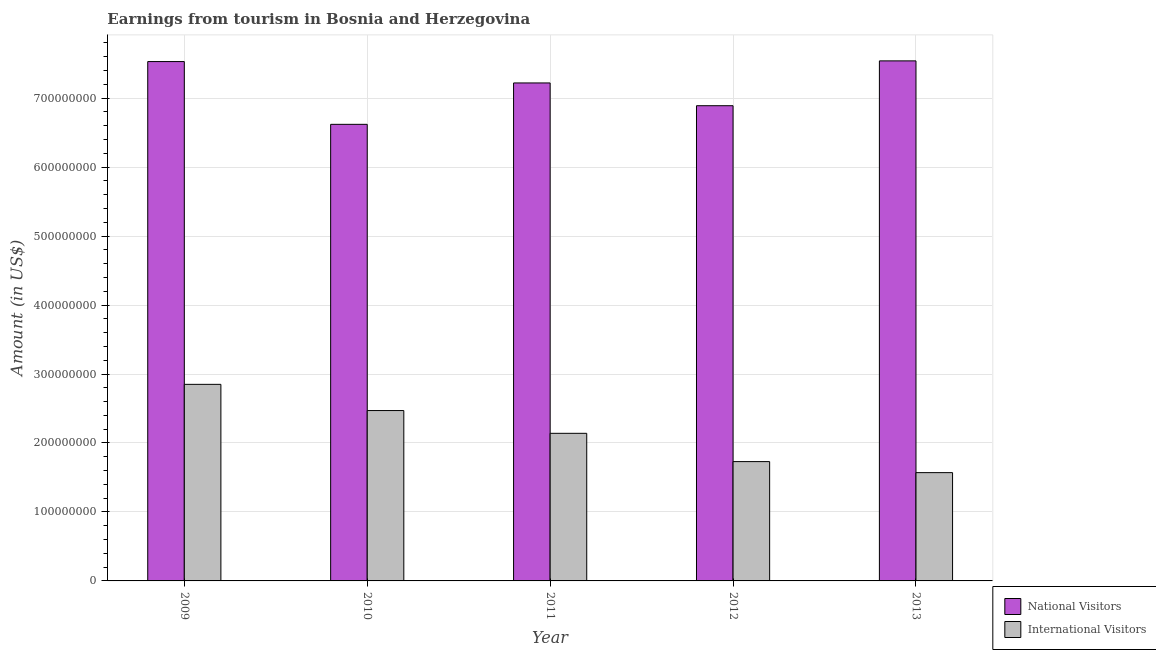Are the number of bars per tick equal to the number of legend labels?
Offer a terse response. Yes. How many bars are there on the 5th tick from the right?
Your response must be concise. 2. What is the label of the 4th group of bars from the left?
Give a very brief answer. 2012. In how many cases, is the number of bars for a given year not equal to the number of legend labels?
Offer a terse response. 0. What is the amount earned from national visitors in 2012?
Provide a short and direct response. 6.89e+08. Across all years, what is the maximum amount earned from national visitors?
Offer a very short reply. 7.54e+08. Across all years, what is the minimum amount earned from national visitors?
Ensure brevity in your answer.  6.62e+08. In which year was the amount earned from international visitors minimum?
Your answer should be compact. 2013. What is the total amount earned from national visitors in the graph?
Offer a very short reply. 3.58e+09. What is the difference between the amount earned from national visitors in 2010 and that in 2012?
Offer a very short reply. -2.70e+07. What is the difference between the amount earned from international visitors in 2013 and the amount earned from national visitors in 2010?
Offer a terse response. -9.00e+07. What is the average amount earned from national visitors per year?
Make the answer very short. 7.16e+08. In the year 2010, what is the difference between the amount earned from international visitors and amount earned from national visitors?
Offer a terse response. 0. In how many years, is the amount earned from international visitors greater than 480000000 US$?
Provide a short and direct response. 0. What is the ratio of the amount earned from international visitors in 2009 to that in 2010?
Provide a short and direct response. 1.15. Is the amount earned from international visitors in 2010 less than that in 2012?
Your response must be concise. No. What is the difference between the highest and the second highest amount earned from international visitors?
Ensure brevity in your answer.  3.80e+07. What is the difference between the highest and the lowest amount earned from national visitors?
Make the answer very short. 9.20e+07. In how many years, is the amount earned from international visitors greater than the average amount earned from international visitors taken over all years?
Offer a terse response. 2. Is the sum of the amount earned from national visitors in 2012 and 2013 greater than the maximum amount earned from international visitors across all years?
Keep it short and to the point. Yes. What does the 1st bar from the left in 2012 represents?
Provide a succinct answer. National Visitors. What does the 2nd bar from the right in 2009 represents?
Offer a terse response. National Visitors. What is the difference between two consecutive major ticks on the Y-axis?
Make the answer very short. 1.00e+08. Are the values on the major ticks of Y-axis written in scientific E-notation?
Your answer should be compact. No. Where does the legend appear in the graph?
Give a very brief answer. Bottom right. How are the legend labels stacked?
Offer a very short reply. Vertical. What is the title of the graph?
Keep it short and to the point. Earnings from tourism in Bosnia and Herzegovina. Does "Passenger Transport Items" appear as one of the legend labels in the graph?
Your response must be concise. No. What is the label or title of the X-axis?
Keep it short and to the point. Year. What is the Amount (in US$) of National Visitors in 2009?
Keep it short and to the point. 7.53e+08. What is the Amount (in US$) in International Visitors in 2009?
Your answer should be compact. 2.85e+08. What is the Amount (in US$) in National Visitors in 2010?
Give a very brief answer. 6.62e+08. What is the Amount (in US$) of International Visitors in 2010?
Offer a terse response. 2.47e+08. What is the Amount (in US$) in National Visitors in 2011?
Keep it short and to the point. 7.22e+08. What is the Amount (in US$) in International Visitors in 2011?
Your answer should be very brief. 2.14e+08. What is the Amount (in US$) of National Visitors in 2012?
Give a very brief answer. 6.89e+08. What is the Amount (in US$) in International Visitors in 2012?
Your answer should be very brief. 1.73e+08. What is the Amount (in US$) in National Visitors in 2013?
Keep it short and to the point. 7.54e+08. What is the Amount (in US$) in International Visitors in 2013?
Ensure brevity in your answer.  1.57e+08. Across all years, what is the maximum Amount (in US$) of National Visitors?
Your answer should be compact. 7.54e+08. Across all years, what is the maximum Amount (in US$) of International Visitors?
Ensure brevity in your answer.  2.85e+08. Across all years, what is the minimum Amount (in US$) in National Visitors?
Make the answer very short. 6.62e+08. Across all years, what is the minimum Amount (in US$) of International Visitors?
Provide a succinct answer. 1.57e+08. What is the total Amount (in US$) of National Visitors in the graph?
Ensure brevity in your answer.  3.58e+09. What is the total Amount (in US$) of International Visitors in the graph?
Make the answer very short. 1.08e+09. What is the difference between the Amount (in US$) of National Visitors in 2009 and that in 2010?
Ensure brevity in your answer.  9.10e+07. What is the difference between the Amount (in US$) in International Visitors in 2009 and that in 2010?
Your answer should be very brief. 3.80e+07. What is the difference between the Amount (in US$) in National Visitors in 2009 and that in 2011?
Provide a succinct answer. 3.10e+07. What is the difference between the Amount (in US$) of International Visitors in 2009 and that in 2011?
Offer a terse response. 7.10e+07. What is the difference between the Amount (in US$) of National Visitors in 2009 and that in 2012?
Give a very brief answer. 6.40e+07. What is the difference between the Amount (in US$) of International Visitors in 2009 and that in 2012?
Give a very brief answer. 1.12e+08. What is the difference between the Amount (in US$) of National Visitors in 2009 and that in 2013?
Your answer should be compact. -1.00e+06. What is the difference between the Amount (in US$) of International Visitors in 2009 and that in 2013?
Keep it short and to the point. 1.28e+08. What is the difference between the Amount (in US$) in National Visitors in 2010 and that in 2011?
Your answer should be very brief. -6.00e+07. What is the difference between the Amount (in US$) of International Visitors in 2010 and that in 2011?
Your response must be concise. 3.30e+07. What is the difference between the Amount (in US$) in National Visitors in 2010 and that in 2012?
Offer a terse response. -2.70e+07. What is the difference between the Amount (in US$) in International Visitors in 2010 and that in 2012?
Your answer should be very brief. 7.40e+07. What is the difference between the Amount (in US$) in National Visitors in 2010 and that in 2013?
Your answer should be very brief. -9.20e+07. What is the difference between the Amount (in US$) in International Visitors in 2010 and that in 2013?
Offer a terse response. 9.00e+07. What is the difference between the Amount (in US$) in National Visitors in 2011 and that in 2012?
Your answer should be very brief. 3.30e+07. What is the difference between the Amount (in US$) in International Visitors in 2011 and that in 2012?
Your answer should be very brief. 4.10e+07. What is the difference between the Amount (in US$) in National Visitors in 2011 and that in 2013?
Your answer should be very brief. -3.20e+07. What is the difference between the Amount (in US$) of International Visitors in 2011 and that in 2013?
Your response must be concise. 5.70e+07. What is the difference between the Amount (in US$) of National Visitors in 2012 and that in 2013?
Offer a terse response. -6.50e+07. What is the difference between the Amount (in US$) of International Visitors in 2012 and that in 2013?
Keep it short and to the point. 1.60e+07. What is the difference between the Amount (in US$) in National Visitors in 2009 and the Amount (in US$) in International Visitors in 2010?
Make the answer very short. 5.06e+08. What is the difference between the Amount (in US$) in National Visitors in 2009 and the Amount (in US$) in International Visitors in 2011?
Ensure brevity in your answer.  5.39e+08. What is the difference between the Amount (in US$) of National Visitors in 2009 and the Amount (in US$) of International Visitors in 2012?
Your answer should be very brief. 5.80e+08. What is the difference between the Amount (in US$) in National Visitors in 2009 and the Amount (in US$) in International Visitors in 2013?
Your response must be concise. 5.96e+08. What is the difference between the Amount (in US$) of National Visitors in 2010 and the Amount (in US$) of International Visitors in 2011?
Provide a short and direct response. 4.48e+08. What is the difference between the Amount (in US$) of National Visitors in 2010 and the Amount (in US$) of International Visitors in 2012?
Your response must be concise. 4.89e+08. What is the difference between the Amount (in US$) in National Visitors in 2010 and the Amount (in US$) in International Visitors in 2013?
Offer a terse response. 5.05e+08. What is the difference between the Amount (in US$) of National Visitors in 2011 and the Amount (in US$) of International Visitors in 2012?
Ensure brevity in your answer.  5.49e+08. What is the difference between the Amount (in US$) in National Visitors in 2011 and the Amount (in US$) in International Visitors in 2013?
Ensure brevity in your answer.  5.65e+08. What is the difference between the Amount (in US$) in National Visitors in 2012 and the Amount (in US$) in International Visitors in 2013?
Your response must be concise. 5.32e+08. What is the average Amount (in US$) of National Visitors per year?
Provide a short and direct response. 7.16e+08. What is the average Amount (in US$) in International Visitors per year?
Provide a short and direct response. 2.15e+08. In the year 2009, what is the difference between the Amount (in US$) in National Visitors and Amount (in US$) in International Visitors?
Your answer should be compact. 4.68e+08. In the year 2010, what is the difference between the Amount (in US$) of National Visitors and Amount (in US$) of International Visitors?
Provide a short and direct response. 4.15e+08. In the year 2011, what is the difference between the Amount (in US$) of National Visitors and Amount (in US$) of International Visitors?
Offer a terse response. 5.08e+08. In the year 2012, what is the difference between the Amount (in US$) of National Visitors and Amount (in US$) of International Visitors?
Ensure brevity in your answer.  5.16e+08. In the year 2013, what is the difference between the Amount (in US$) of National Visitors and Amount (in US$) of International Visitors?
Offer a terse response. 5.97e+08. What is the ratio of the Amount (in US$) of National Visitors in 2009 to that in 2010?
Your response must be concise. 1.14. What is the ratio of the Amount (in US$) of International Visitors in 2009 to that in 2010?
Keep it short and to the point. 1.15. What is the ratio of the Amount (in US$) in National Visitors in 2009 to that in 2011?
Your answer should be compact. 1.04. What is the ratio of the Amount (in US$) in International Visitors in 2009 to that in 2011?
Make the answer very short. 1.33. What is the ratio of the Amount (in US$) of National Visitors in 2009 to that in 2012?
Your answer should be very brief. 1.09. What is the ratio of the Amount (in US$) in International Visitors in 2009 to that in 2012?
Provide a succinct answer. 1.65. What is the ratio of the Amount (in US$) of International Visitors in 2009 to that in 2013?
Your answer should be very brief. 1.82. What is the ratio of the Amount (in US$) in National Visitors in 2010 to that in 2011?
Your answer should be compact. 0.92. What is the ratio of the Amount (in US$) in International Visitors in 2010 to that in 2011?
Provide a succinct answer. 1.15. What is the ratio of the Amount (in US$) in National Visitors in 2010 to that in 2012?
Your answer should be compact. 0.96. What is the ratio of the Amount (in US$) in International Visitors in 2010 to that in 2012?
Offer a terse response. 1.43. What is the ratio of the Amount (in US$) in National Visitors in 2010 to that in 2013?
Give a very brief answer. 0.88. What is the ratio of the Amount (in US$) of International Visitors in 2010 to that in 2013?
Keep it short and to the point. 1.57. What is the ratio of the Amount (in US$) of National Visitors in 2011 to that in 2012?
Your response must be concise. 1.05. What is the ratio of the Amount (in US$) in International Visitors in 2011 to that in 2012?
Make the answer very short. 1.24. What is the ratio of the Amount (in US$) of National Visitors in 2011 to that in 2013?
Ensure brevity in your answer.  0.96. What is the ratio of the Amount (in US$) of International Visitors in 2011 to that in 2013?
Offer a very short reply. 1.36. What is the ratio of the Amount (in US$) of National Visitors in 2012 to that in 2013?
Ensure brevity in your answer.  0.91. What is the ratio of the Amount (in US$) in International Visitors in 2012 to that in 2013?
Make the answer very short. 1.1. What is the difference between the highest and the second highest Amount (in US$) in International Visitors?
Your answer should be very brief. 3.80e+07. What is the difference between the highest and the lowest Amount (in US$) in National Visitors?
Provide a succinct answer. 9.20e+07. What is the difference between the highest and the lowest Amount (in US$) in International Visitors?
Keep it short and to the point. 1.28e+08. 